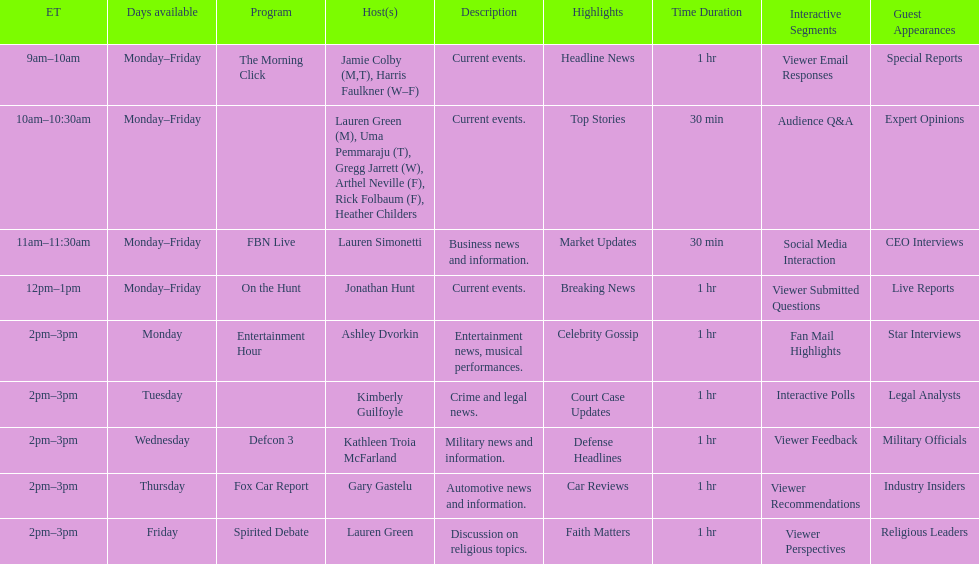How long does on the hunt run? 1 hour. 